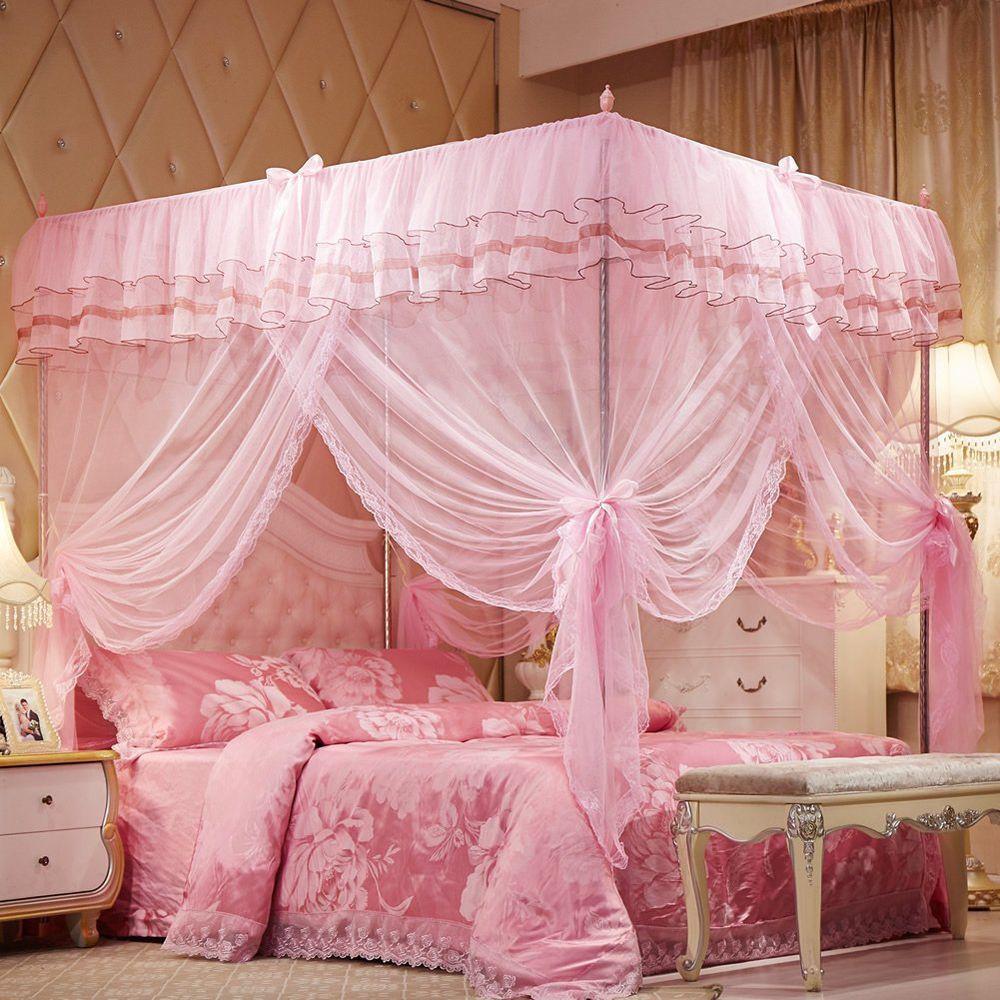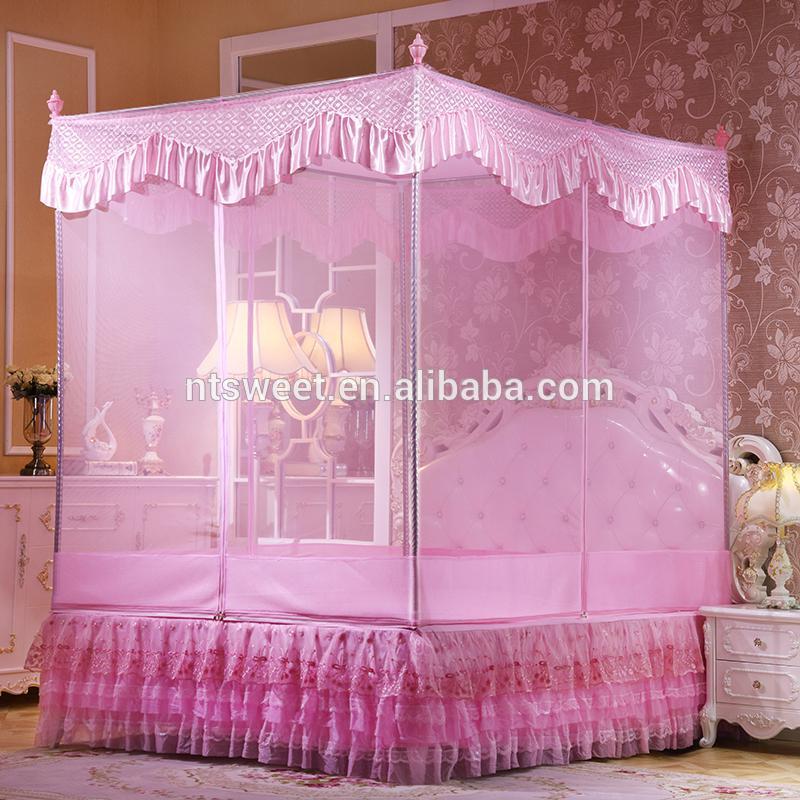The first image is the image on the left, the second image is the image on the right. Evaluate the accuracy of this statement regarding the images: "At least one of the beds has a pink bedspread.". Is it true? Answer yes or no. Yes. 